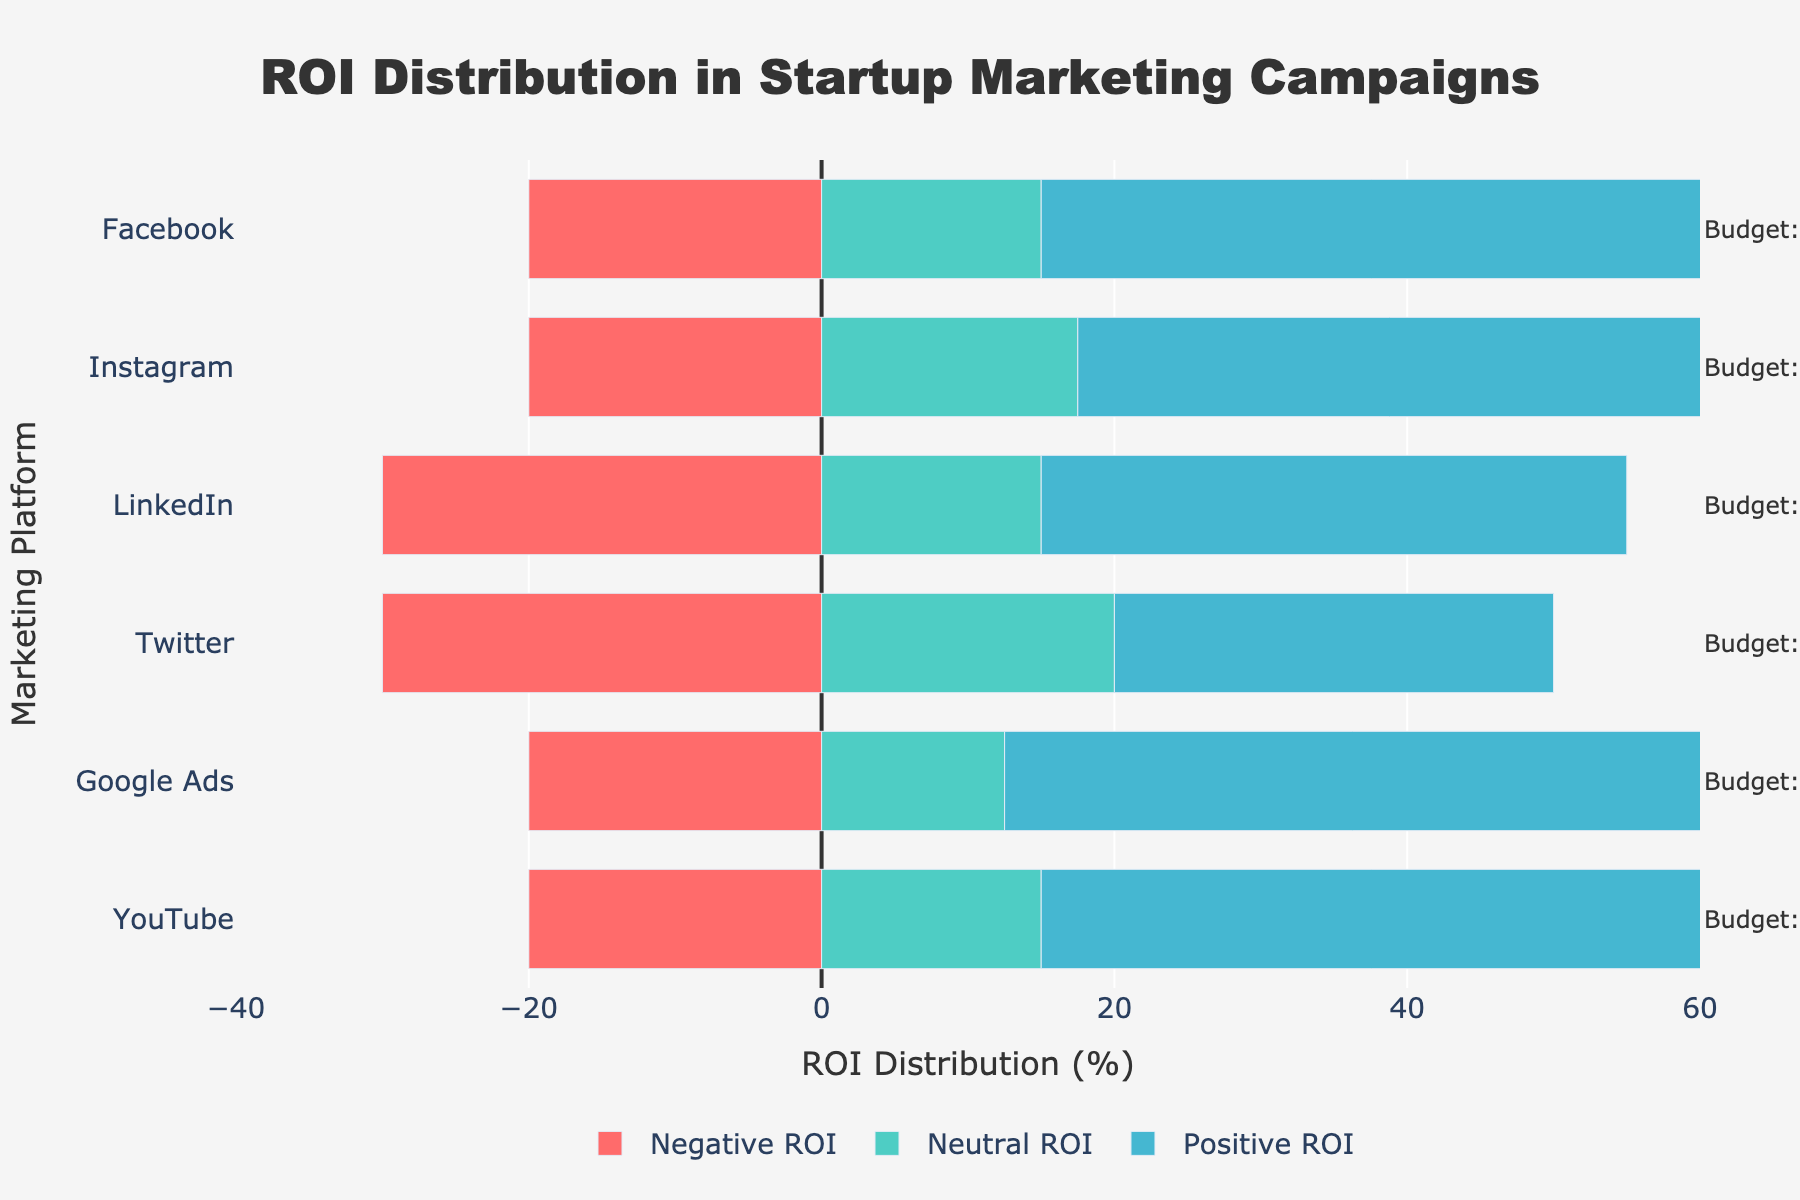what platform has the highest percentage of neutral ROI? To determine the platform with the highest percentage of neutral ROI, observe the green bars, which represent neutral ROI. The highest green bar is for Twitter.
Answer: Twitter which platform has the highest percentage of negative ROI? To determine which platform has the highest percentage of negative ROI, observe the red bars, which represent negative ROI. The longest red bar belongs to LinkedIn.
Answer: LinkedIn compare the percentage of positive ROI between Google Ads and Facebook. Which one is higher? Google Ads has a blue bar labeled "Positive ROI" extending to 55%, while Facebook's positive ROI extends to 50%. Therefore, Google Ads has the higher percentage of positive ROI.
Answer: Google Ads what is the total percentage of neutral and negative ROI for YouTube? For YouTube, the negative ROI is -20% (to the left) and the neutral ROI is 15% (half of 30% since the neutral is divided in the middle). Summing these, -20 + 15 = -5%, so, combining the two would be 20% as a positive value for final calculation purposes.
Answer: 20% calculate the average positive ROI across all platforms. Average positive ROI is calculated by summing up all the positive ROI values and dividing by the number of platforms: (50% + 45% + 40% + 30% + 55% + 50%) / 6 = 270 / 6 = 45%
Answer: 45% which platform has the closest balance between positive and negative ROI? To determine the closest balance between positive and negative ROI, check the difference between these two values for each platform. LinkedIn has the closest balance, with +40% positive and -30% negative ROI.
Answer: LinkedIn among the platforms with a positive ROI greater than or equal to 50%, which one has the largest neutral ROI? The platforms with positive ROI of 50% or more are Facebook, Google Ads, and YouTube. Among them, observe the green bars for neutral ROI. Facebook and YouTube have 30%, Google Ads has 25%, so Facebook and YouTube have the largest neutral ROI.
Answer: Facebook, YouTube what is the percentage difference in positive ROI between the platform with the highest and the one with the lowest positive ROI? The highest positive ROI is 55% (Google Ads), and the lowest is 30% (Twitter). The difference is 55% - 30% = 25%.
Answer: 25% is the combined positive and neutral ROI for any platform below 60%? If so, which one(s)? Adding both positive and neutral ROI for each platform: Facebook: 80%, Instagram: 80%, LinkedIn: 70%, Twitter: 70%, Google Ads: 80%, YouTube: 65%. None of the platforms have a combined positive and neutral ROI below 60%.
Answer: No platforms 